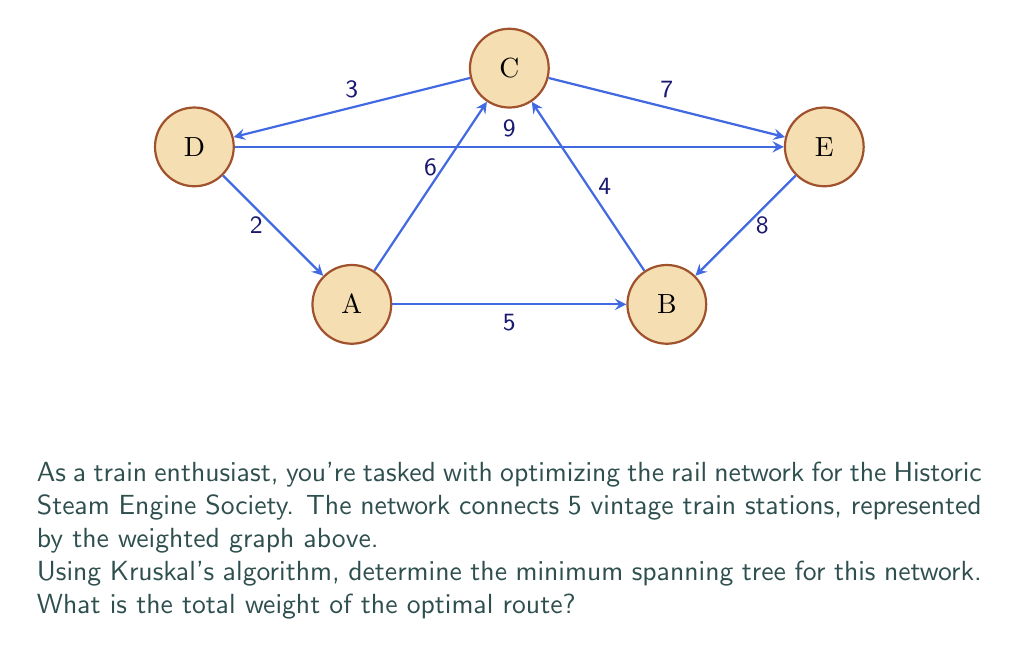Solve this math problem. Let's apply Kruskal's algorithm step-by-step to find the minimum spanning tree:

1) First, sort all edges by weight in ascending order:
   $$(D,A): 2, (C,D): 3, (B,C): 4, (A,B): 5, (A,C): 6, (C,E): 7, (E,B): 8, (D,E): 9$$

2) Start with an empty set of edges and add edges in order if they don't create a cycle:

   - Add $(D,A): 2$
   - Add $(C,D): 3$
   - Add $(B,C): 4$
   - Skip $(A,B): 5$ as it would create a cycle
   - Skip $(A,C): 6$ as it would create a cycle
   - Add $(C,E): 7$

3) We now have a minimum spanning tree connecting all 5 vertices:

   $$(D,A), (C,D), (B,C), (C,E)$$

4) Calculate the total weight:
   $$2 + 3 + 4 + 7 = 16$$

Therefore, the minimum spanning tree has a total weight of 16.
Answer: 16 